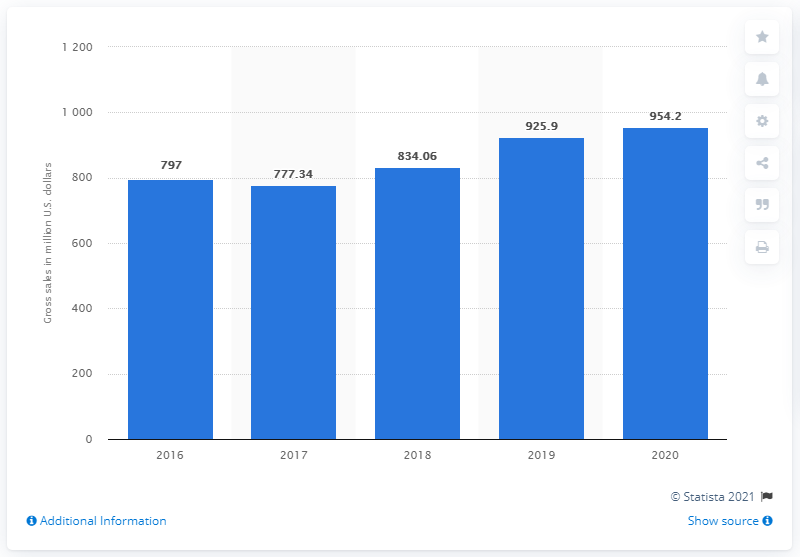Outline some significant characteristics in this image. Mattel's Hot Wheels brand generated a total of 954.2 million U.S. dollars in 2019. Mattel's Hot Wheels brand achieved gross sales of 925.9 million in the previous year. 